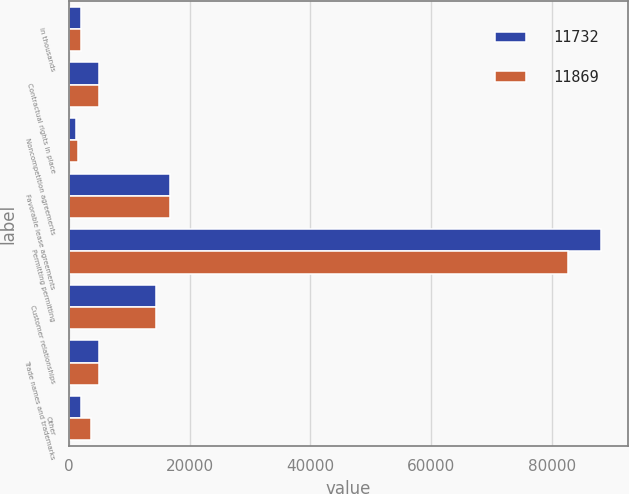Convert chart. <chart><loc_0><loc_0><loc_500><loc_500><stacked_bar_chart><ecel><fcel>in thousands<fcel>Contractual rights in place<fcel>Noncompetition agreements<fcel>Favorable lease agreements<fcel>Permitting permitting<fcel>Customer relationships<fcel>Trade names and trademarks<fcel>Other<nl><fcel>11732<fcel>2013<fcel>5006<fcel>1200<fcel>16677<fcel>88113<fcel>14393<fcel>5006<fcel>2014<nl><fcel>11869<fcel>2012<fcel>5006<fcel>1450<fcel>16677<fcel>82596<fcel>14493<fcel>5006<fcel>3711<nl></chart> 